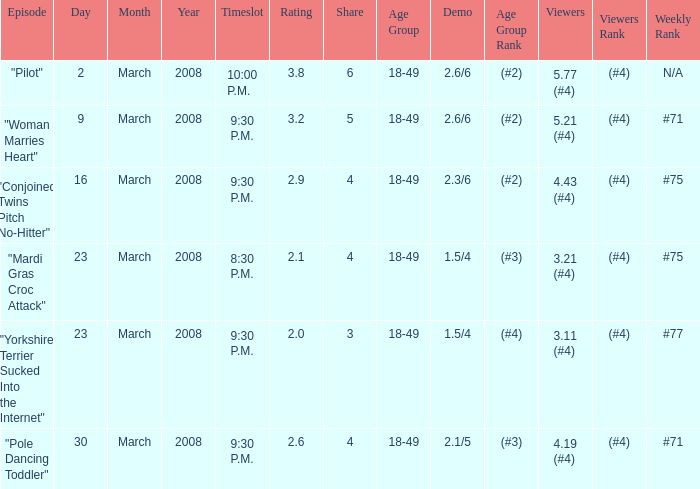What is the total ratings on share less than 4? 1.0. 